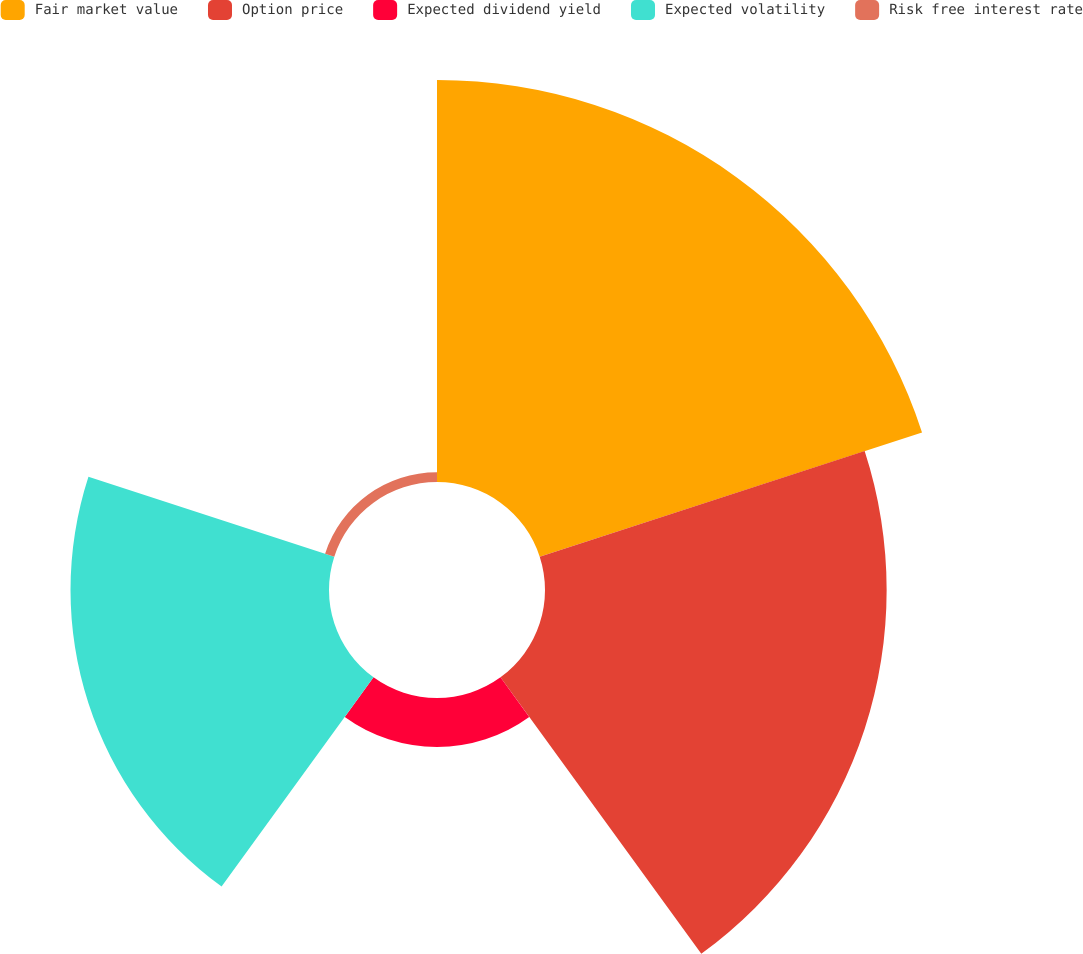<chart> <loc_0><loc_0><loc_500><loc_500><pie_chart><fcel>Fair market value<fcel>Option price<fcel>Expected dividend yield<fcel>Expected volatility<fcel>Risk free interest rate<nl><fcel>37.9%<fcel>32.21%<fcel>4.61%<fcel>24.37%<fcel>0.91%<nl></chart> 